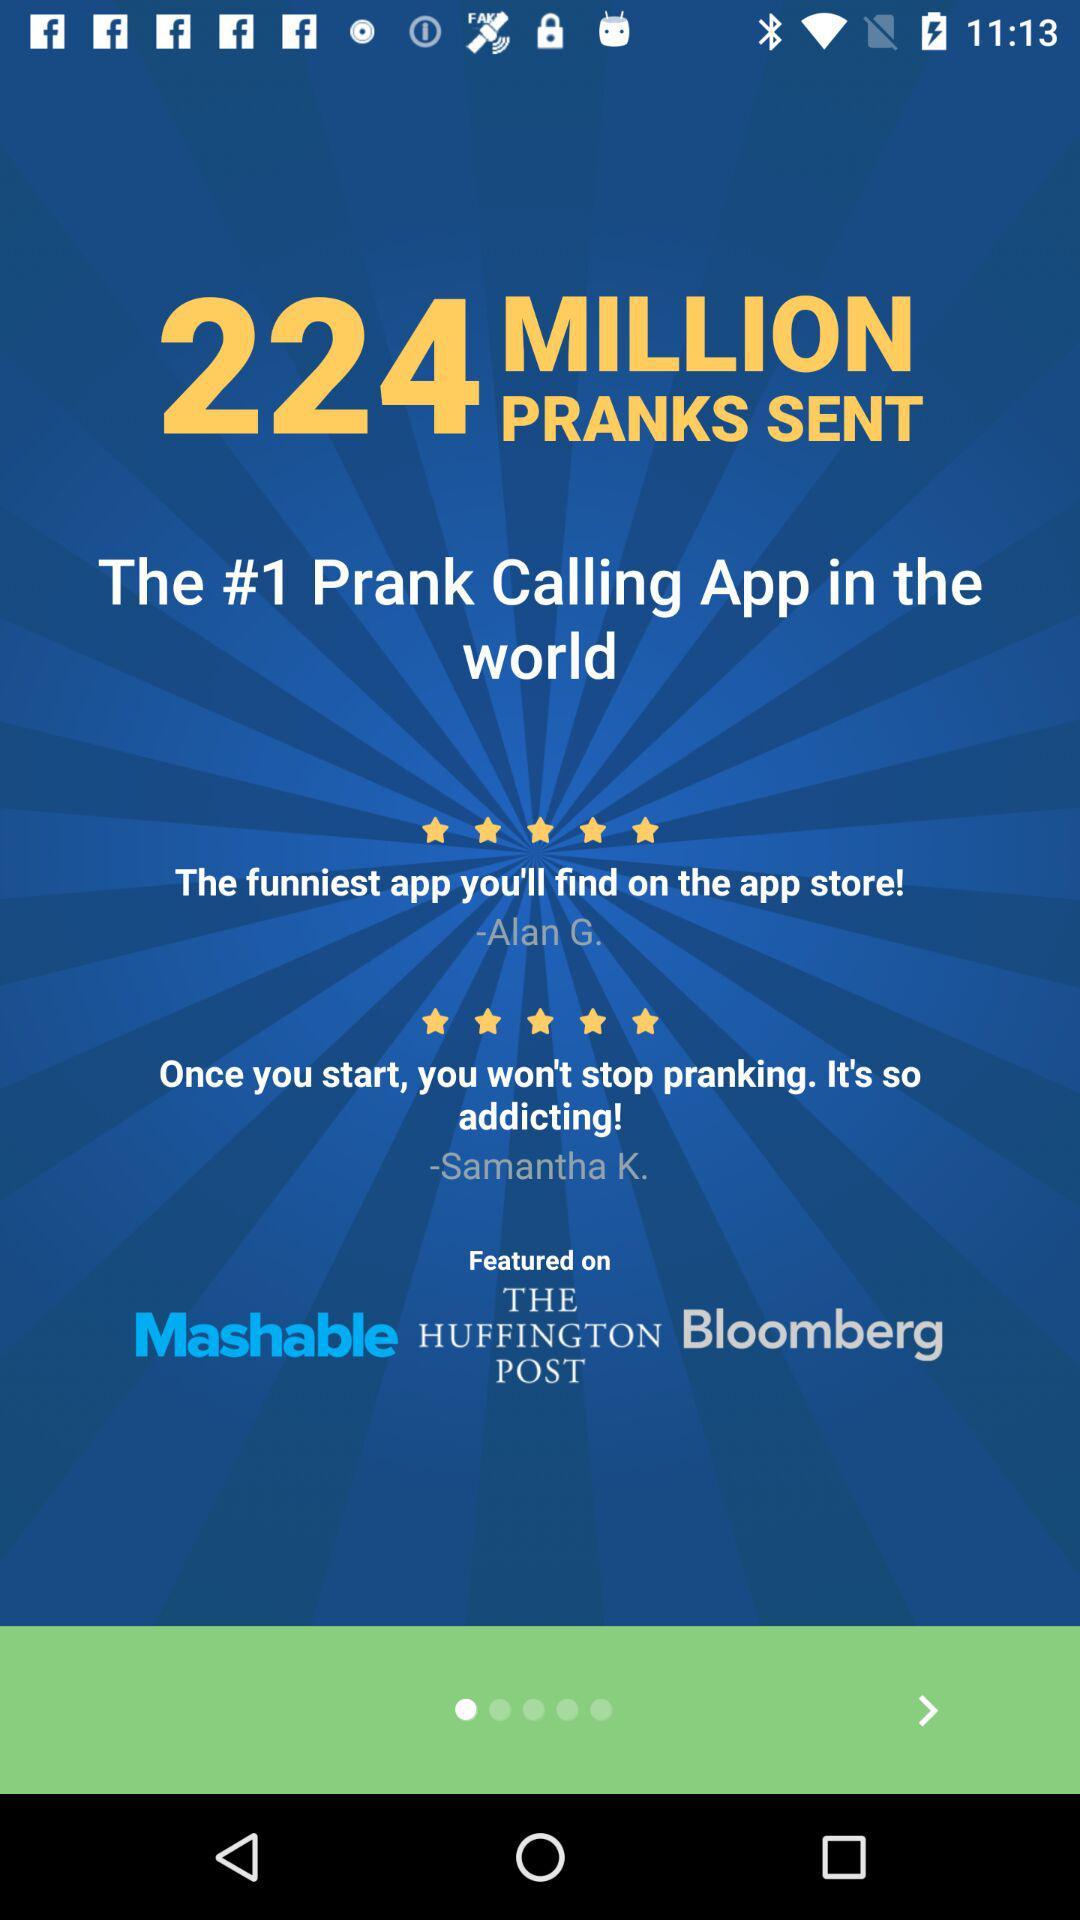Who is the founder of the prank calling application?
When the provided information is insufficient, respond with <no answer>. <no answer> 